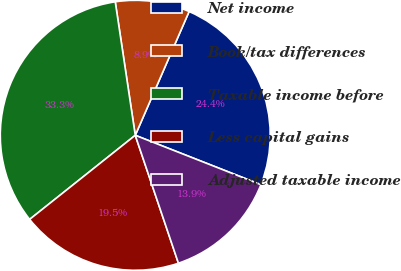<chart> <loc_0><loc_0><loc_500><loc_500><pie_chart><fcel>Net income<fcel>Book/tax differences<fcel>Taxable income before<fcel>Less capital gains<fcel>Adjusted taxable income<nl><fcel>24.43%<fcel>8.9%<fcel>33.33%<fcel>19.48%<fcel>13.86%<nl></chart> 